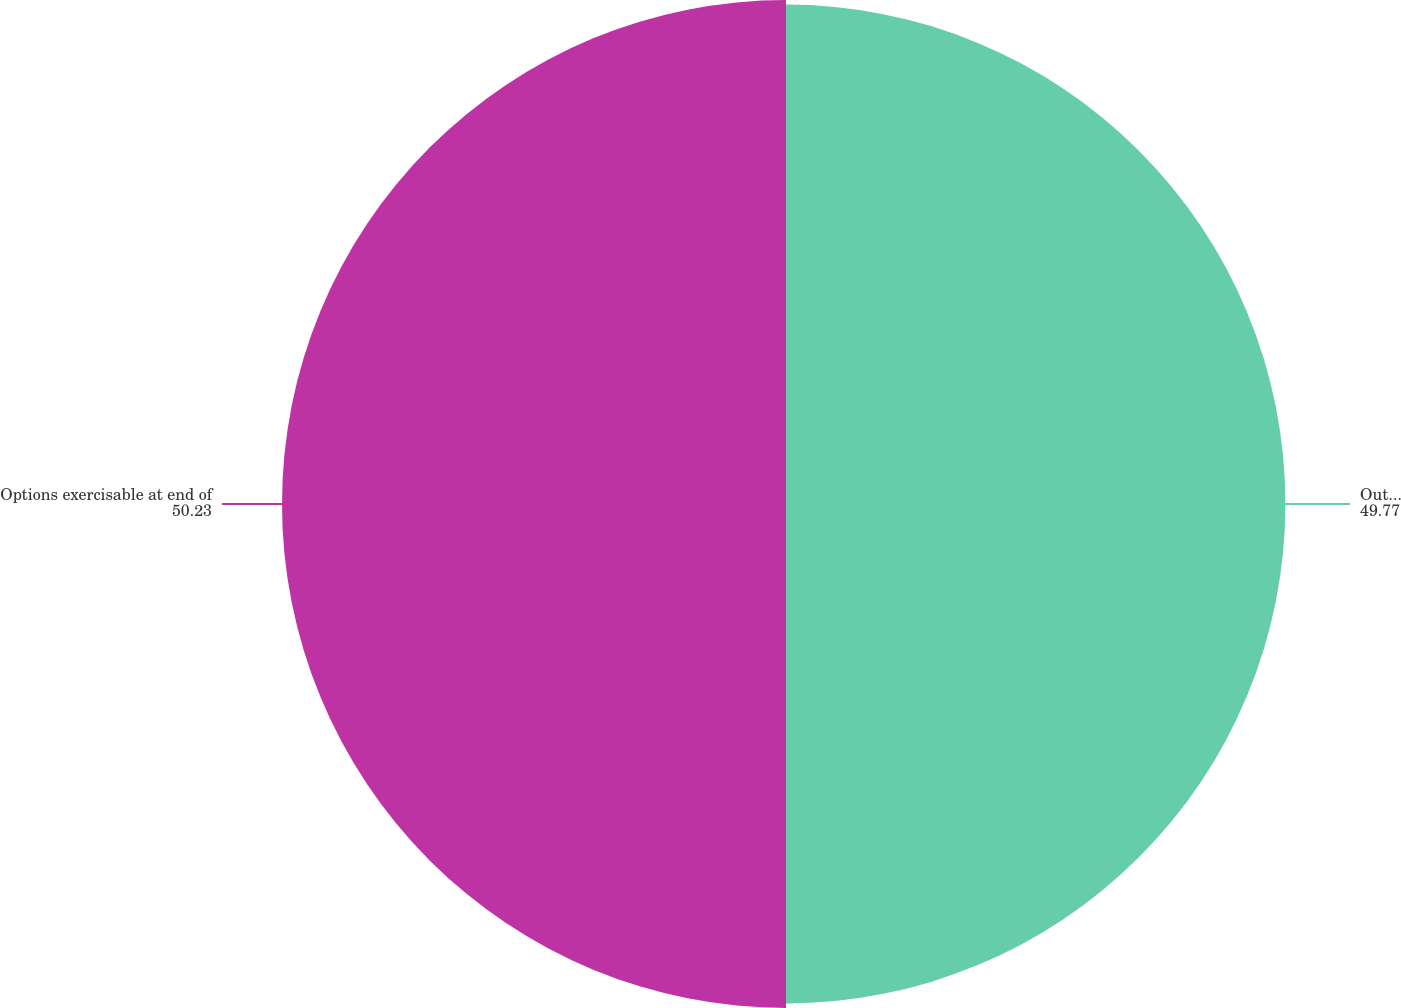Convert chart to OTSL. <chart><loc_0><loc_0><loc_500><loc_500><pie_chart><fcel>Outstanding at end of period<fcel>Options exercisable at end of<nl><fcel>49.77%<fcel>50.23%<nl></chart> 